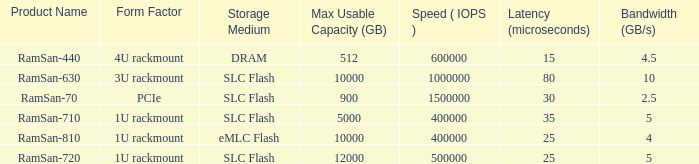How many ramsan-720 hard drives are there? 1.0. 